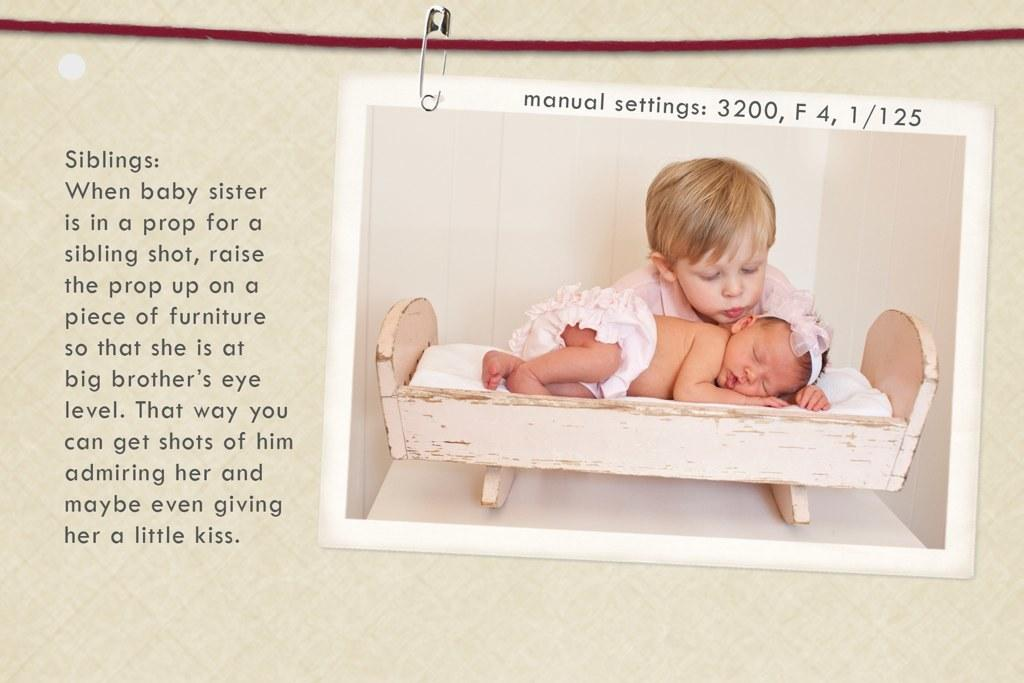What is the main object in the image? There is a poster in the image. What can be seen on the left side of the poster? There is: There is text on the left side of the poster. What image is depicted on the poster? There is an image of a baby sleeping on the poster. Are there any other elements on the poster besides the text and the sleeping baby? Yes, there is a child present behind the sleeping baby on the poster, and there is a safety pin on the top of the poster. What type of song is playing in the background of the image? There is no information about any song playing in the background of the image. The image only shows a poster with text, an image of a baby sleeping, a child, and a safety pin. 